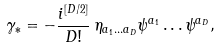<formula> <loc_0><loc_0><loc_500><loc_500>\gamma _ { * } = - \frac { i ^ { [ D / 2 ] } } { D ! } \, \eta _ { a _ { 1 } \dots a _ { D } } \psi ^ { a _ { 1 } } \dots \psi ^ { a _ { D } } ,</formula> 